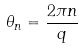<formula> <loc_0><loc_0><loc_500><loc_500>\theta _ { n } = \frac { 2 \pi n } { q }</formula> 